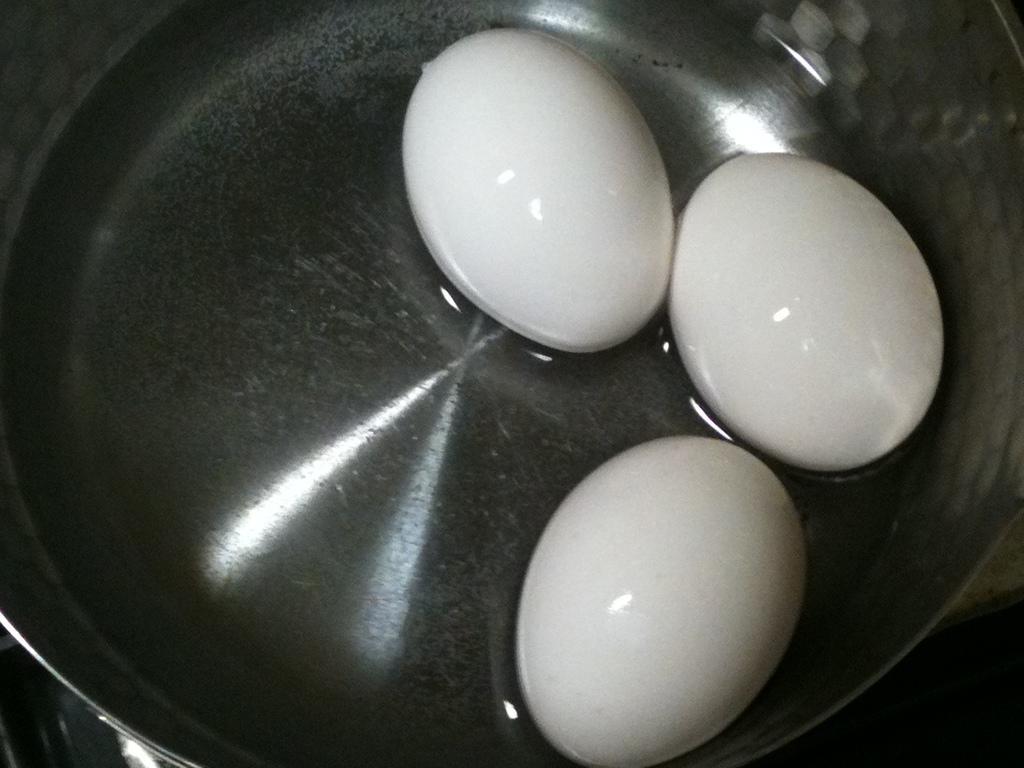Describe this image in one or two sentences. In the picture we can see a bowl with some water and three eggs in it which are white in color. 